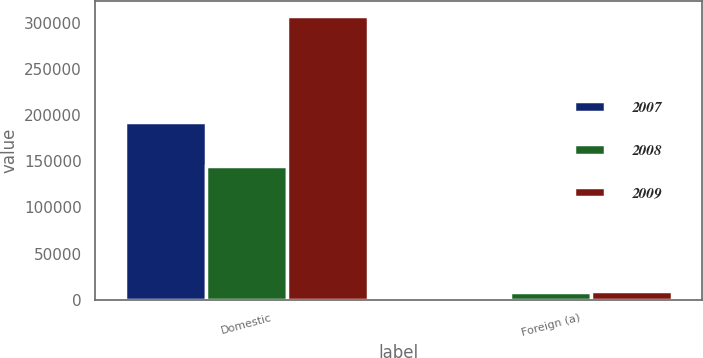Convert chart to OTSL. <chart><loc_0><loc_0><loc_500><loc_500><stacked_bar_chart><ecel><fcel>Domestic<fcel>Foreign (a)<nl><fcel>2007<fcel>193055<fcel>2532<nl><fcel>2008<fcel>145086<fcel>8133<nl><fcel>2009<fcel>307953<fcel>9050<nl></chart> 